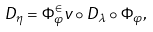<formula> <loc_0><loc_0><loc_500><loc_500>D _ { \eta } = \Phi _ { \varphi } ^ { \in } v \circ D _ { \lambda } \circ \Phi _ { \varphi } ,</formula> 